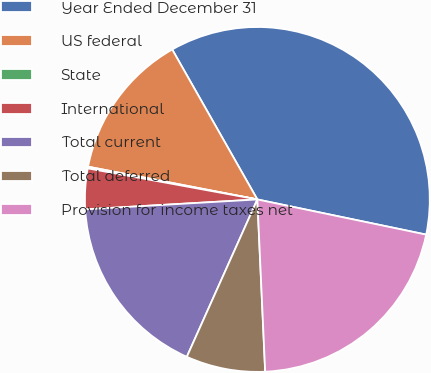<chart> <loc_0><loc_0><loc_500><loc_500><pie_chart><fcel>Year Ended December 31<fcel>US federal<fcel>State<fcel>International<fcel>Total current<fcel>Total deferred<fcel>Provision for income taxes net<nl><fcel>36.49%<fcel>13.74%<fcel>0.16%<fcel>3.8%<fcel>17.38%<fcel>7.43%<fcel>21.01%<nl></chart> 